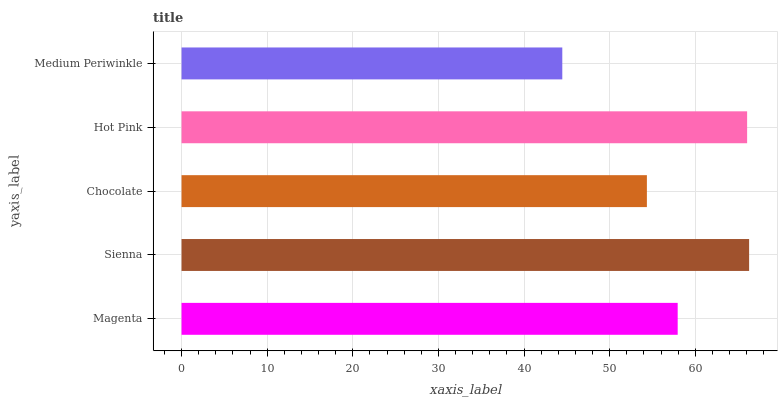Is Medium Periwinkle the minimum?
Answer yes or no. Yes. Is Sienna the maximum?
Answer yes or no. Yes. Is Chocolate the minimum?
Answer yes or no. No. Is Chocolate the maximum?
Answer yes or no. No. Is Sienna greater than Chocolate?
Answer yes or no. Yes. Is Chocolate less than Sienna?
Answer yes or no. Yes. Is Chocolate greater than Sienna?
Answer yes or no. No. Is Sienna less than Chocolate?
Answer yes or no. No. Is Magenta the high median?
Answer yes or no. Yes. Is Magenta the low median?
Answer yes or no. Yes. Is Sienna the high median?
Answer yes or no. No. Is Sienna the low median?
Answer yes or no. No. 